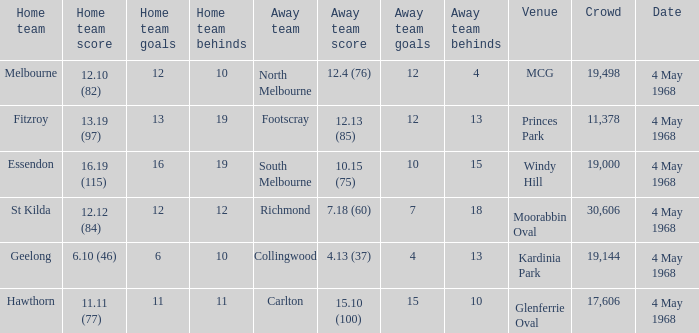What home team played at MCG? North Melbourne. 